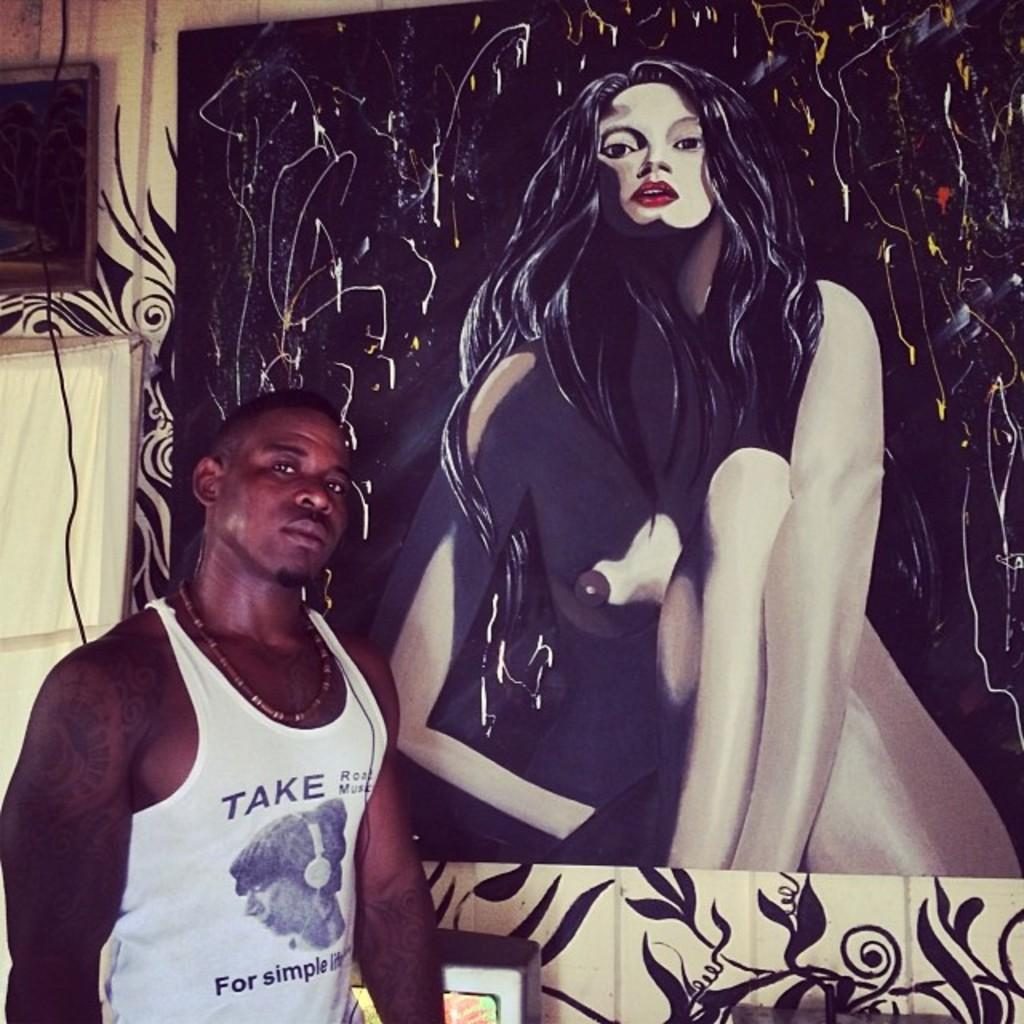<image>
Give a short and clear explanation of the subsequent image. A man is posing next to a painting of a woman. 